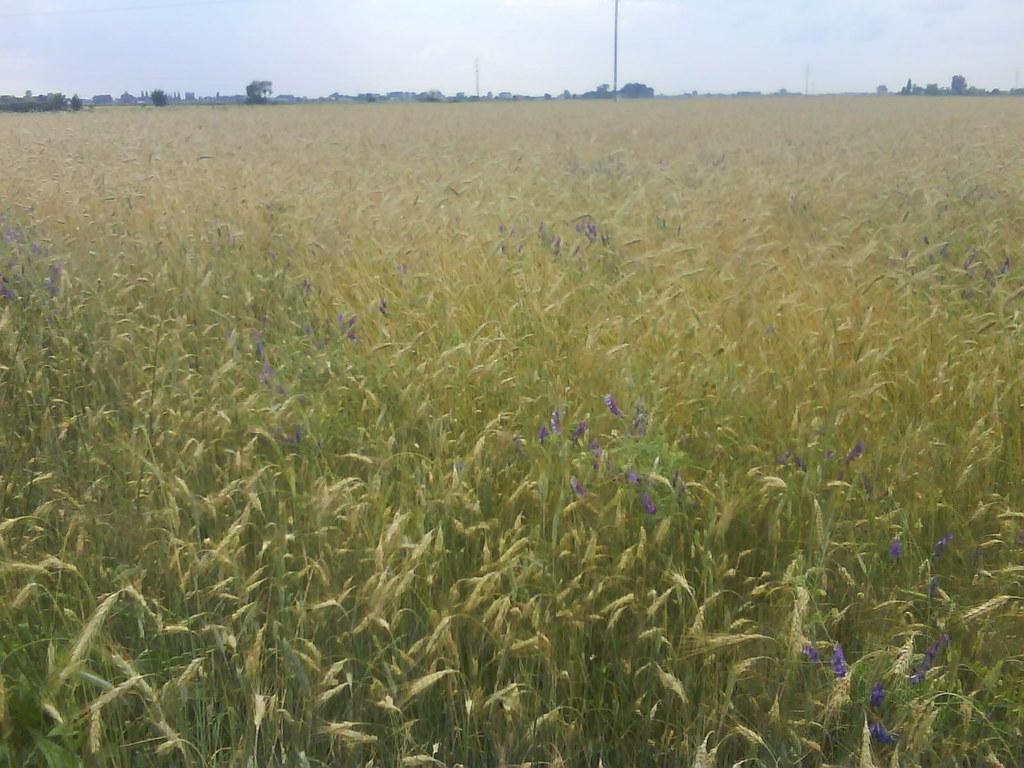What type of living organisms can be seen in the image? Plants and flowers are visible in the image. What color are the plants in the image? The plants are green. What color are the flowers in the image? The flowers are purple. What can be seen in the background of the image? There are poles in the background of the image. What is the color of the sky in the image? The sky is white in color. What type of popcorn can be seen growing on the plants in the image? There is no popcorn present in the image; it is a picture of plants and flowers. What is the interest rate on the flowers in the image? There is no interest rate associated with the flowers in the image; they are simply a part of the natural environment. 